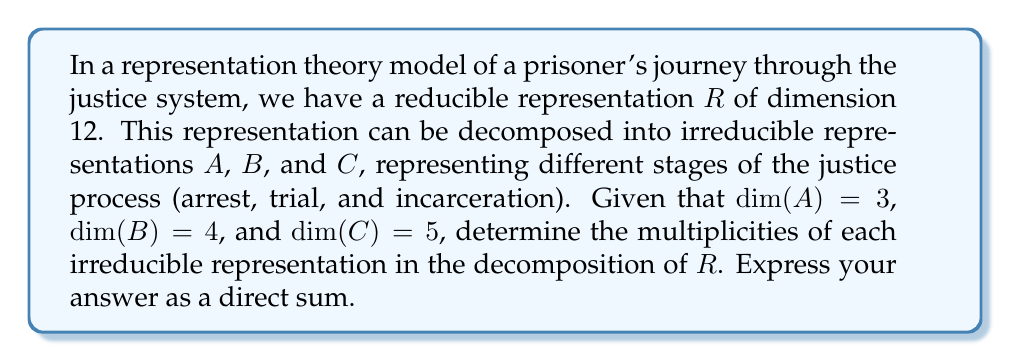Provide a solution to this math problem. To solve this problem, we'll follow these steps:

1) First, recall that for a reducible representation $R$, we can express it as a direct sum of irreducible representations:

   $R = m_A A \oplus m_B B \oplus m_C C$

   where $m_A$, $m_B$, and $m_C$ are the multiplicities of $A$, $B$, and $C$ respectively.

2) We know that the dimension of $R$ is the sum of the dimensions of its irreducible components:

   $\dim(R) = m_A \dim(A) + m_B \dim(B) + m_C \dim(C)$

3) Substituting the given dimensions:

   $12 = 3m_A + 4m_B + 5m_C$

4) This is a Diophantine equation. We need to find non-negative integer solutions for $m_A$, $m_B$, and $m_C$.

5) By inspection, we can see that $m_A = 2$, $m_B = 1$, and $m_C = 1$ satisfies this equation:

   $12 = 3(2) + 4(1) + 5(1)$

6) This solution is unique for non-negative integers, as any other combination would either exceed 12 or fall short.

Therefore, the decomposition of $R$ is $2A \oplus B \oplus C$.
Answer: $R = 2A \oplus B \oplus C$ 